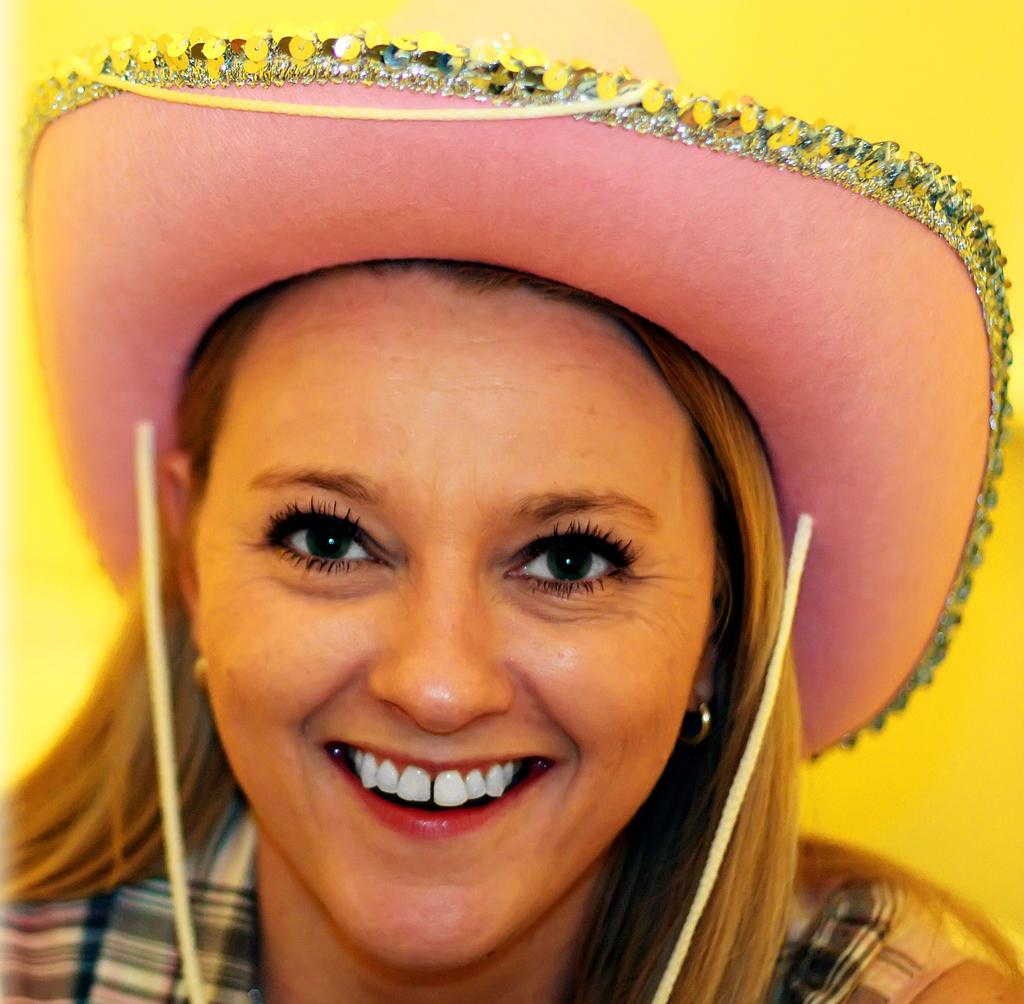Who is present in the image? There is a woman in the image. What is the woman doing in the image? The woman is smiling in the image. What is the woman wearing on her head? The woman is wearing a hat in the image. What color is the background of the image? The background of the image is yellow. What type of creature is crawling on the woman's vest in the image? There is no creature crawling on a vest in the image, as the woman is not wearing a vest. 